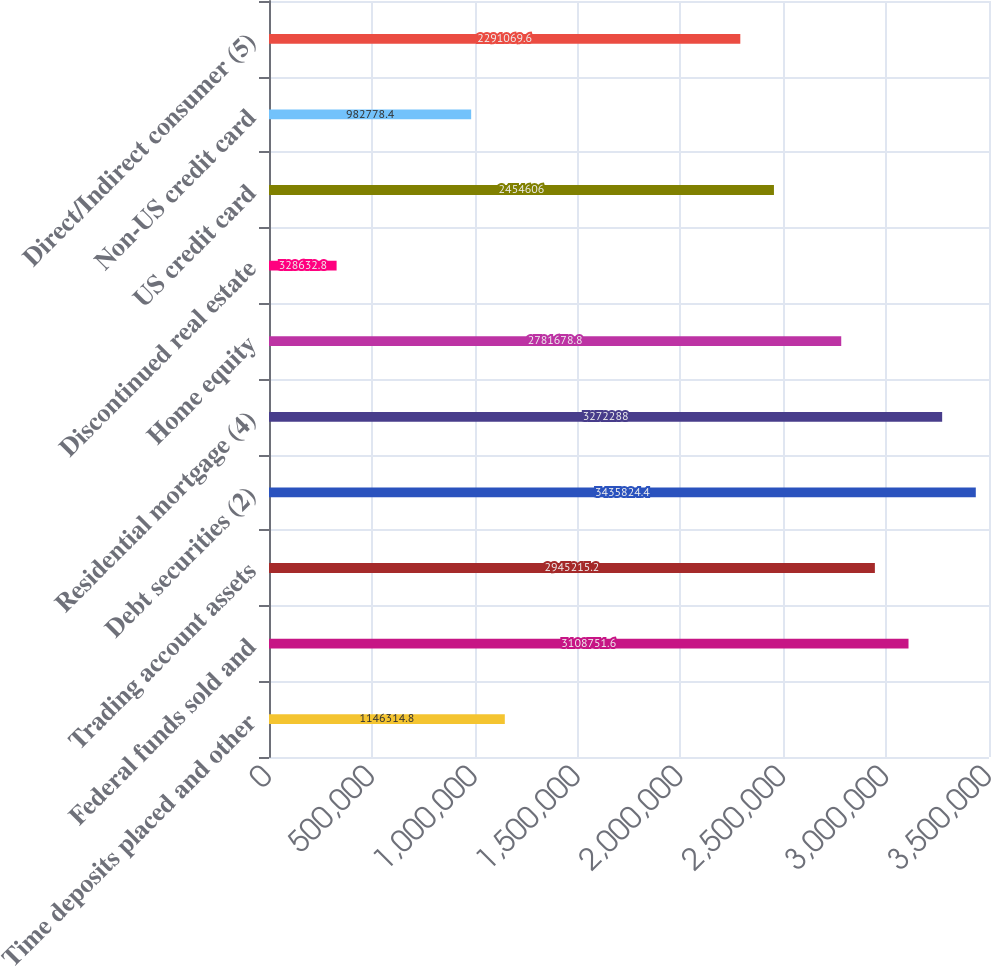Convert chart to OTSL. <chart><loc_0><loc_0><loc_500><loc_500><bar_chart><fcel>Time deposits placed and other<fcel>Federal funds sold and<fcel>Trading account assets<fcel>Debt securities (2)<fcel>Residential mortgage (4)<fcel>Home equity<fcel>Discontinued real estate<fcel>US credit card<fcel>Non-US credit card<fcel>Direct/Indirect consumer (5)<nl><fcel>1.14631e+06<fcel>3.10875e+06<fcel>2.94522e+06<fcel>3.43582e+06<fcel>3.27229e+06<fcel>2.78168e+06<fcel>328633<fcel>2.45461e+06<fcel>982778<fcel>2.29107e+06<nl></chart> 